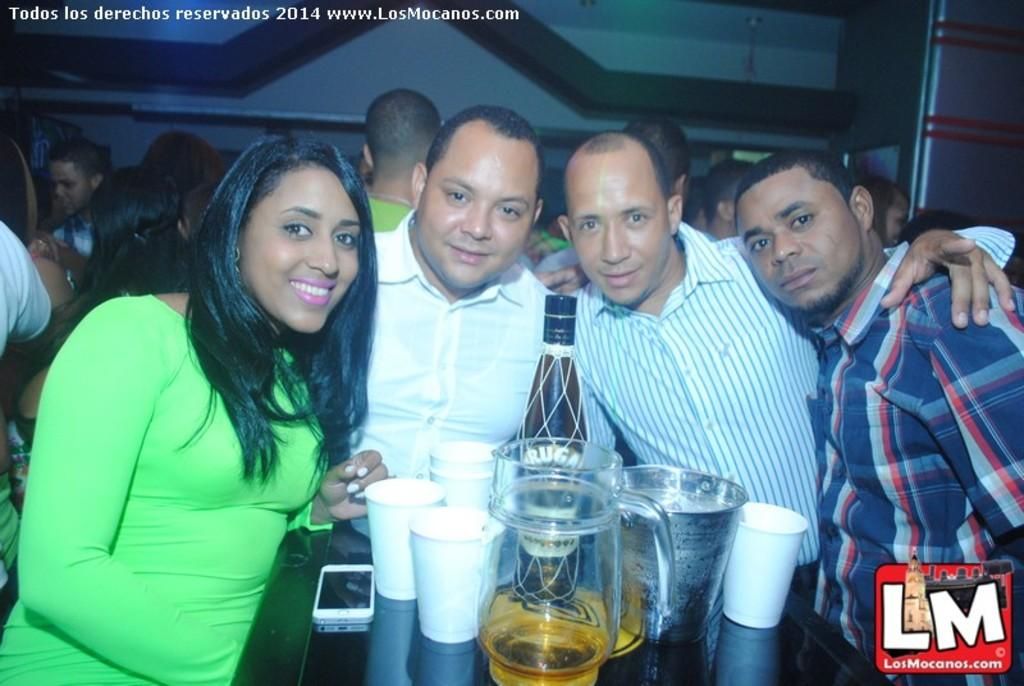What is happening in the image? There are people standing in the image. What is on the table in the image? There is a jug, glasses, a can, and a mobile on the table. Can you describe the table setting in the image? The table has a jug, glasses, a can, and a mobile on it. What is visible in the background of the image? There are people and a wall in the background of the image. What type of grain is being used to make the mobile in the image? There is no grain present in the image, and the mobile is not made of grain. Is there an argument happening between the people in the background of the image? There is no indication of an argument in the image; the people in the background are simply visible. 